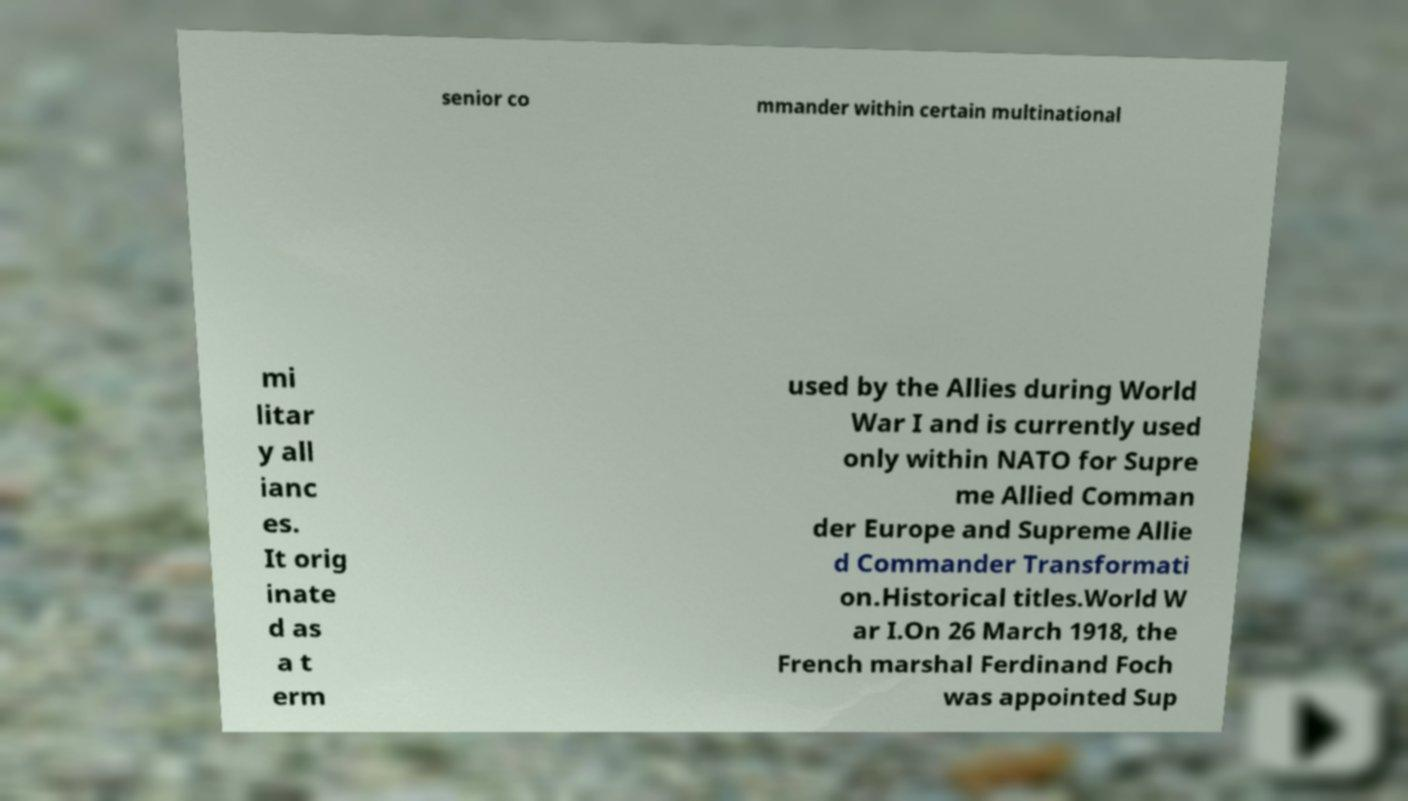Could you assist in decoding the text presented in this image and type it out clearly? senior co mmander within certain multinational mi litar y all ianc es. It orig inate d as a t erm used by the Allies during World War I and is currently used only within NATO for Supre me Allied Comman der Europe and Supreme Allie d Commander Transformati on.Historical titles.World W ar I.On 26 March 1918, the French marshal Ferdinand Foch was appointed Sup 